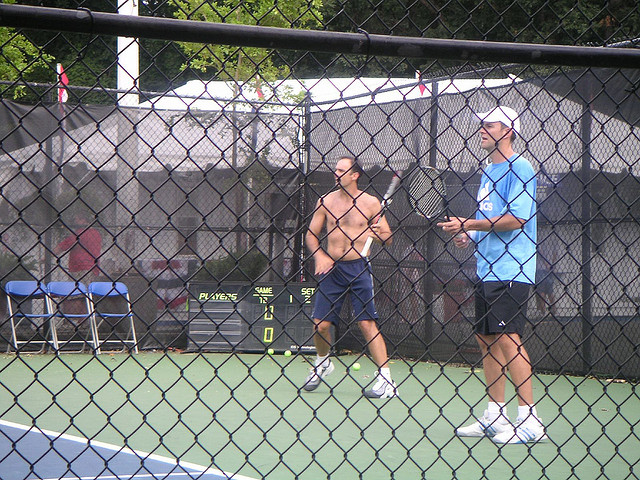Read and extract the text from this image. PLAYERS SAME 0 12 I SET 